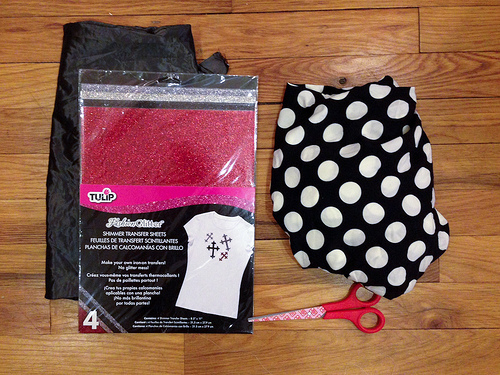<image>
Is the scissor to the left of the cloth? No. The scissor is not to the left of the cloth. From this viewpoint, they have a different horizontal relationship. Where is the scissors in relation to the shirt? Is it under the shirt? No. The scissors is not positioned under the shirt. The vertical relationship between these objects is different. 